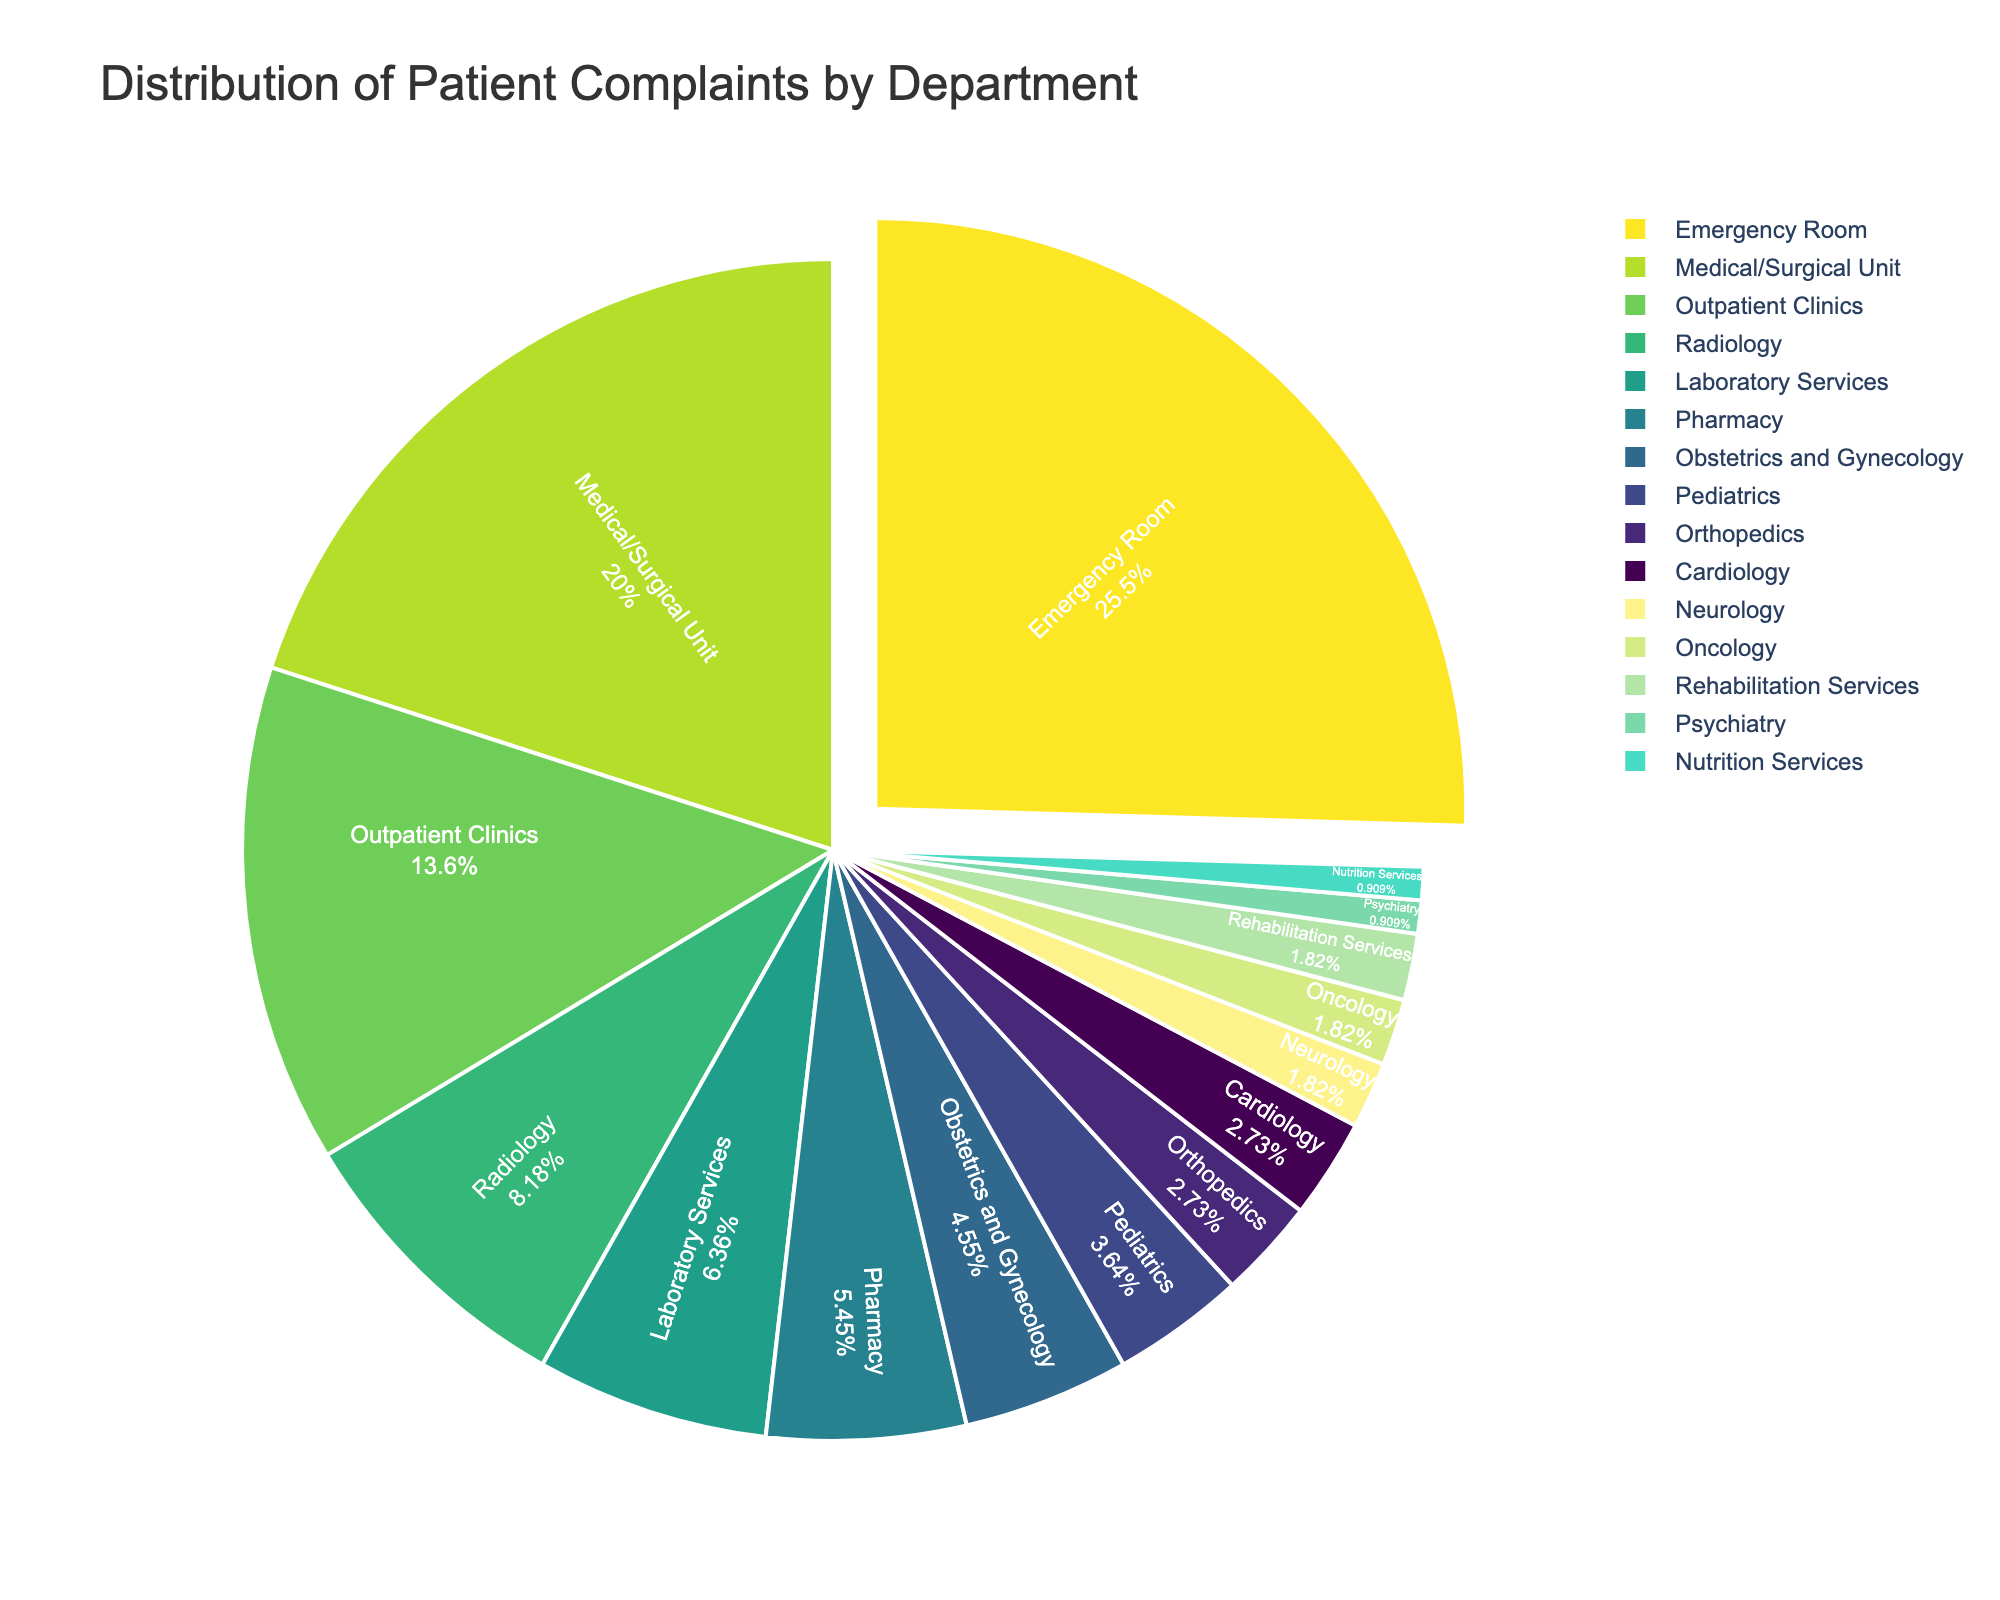What department has the highest percentage of patient complaints? The figure shows that the Emergency Room has the largest segment, which indicates it has the highest percentage of patient complaints.
Answer: Emergency Room Which department has fewer complaints, Orthopedics or Cardiology? Both Orthopedics and Cardiology are represented as small segments. By comparing the labeled percentages, it's visible that both have 3%. Therefore, they have the same percentage of complaints.
Answer: Orthopedics and Cardiology have the same percentage of complaints What is the combined percentage of complaints from the Radiology and Laboratory Services departments? The percentage for Radiology is 9% and for Laboratory Services is 7%. Adding them together gives 9% + 7% = 16%.
Answer: 16% Which two departments have the lowest percentage of complaints? The smallest segments in the pie chart represent Psychiatry and Nutrition Services, each labeled with 1%.
Answer: Psychiatry and Nutrition Services What is the sum of the percentages for Pediatrics, Orthopedics, Cardiology, Neurology, Oncology, Rehabilitation Services, Psychiatry, and Nutrition Services? The percentages for these departments are:
Pediatrics: 4%, Orthopedics: 3%, Cardiology: 3%, Neurology: 2%, Oncology: 2%, Rehabilitation Services: 2%, Psychiatry: 1%, Nutrition Services: 1%.
Adding these together: 4% + 3% + 3% + 2% + 2% + 2% + 1% + 1% = 18%.
Answer: 18% What percentage of complaints come from the departments with fewer than 5% complaints each? Departments with fewer than 5% include Obstetrics and Gynecology (5%), Pediatrics (4%), Orthopedics (3%), Cardiology (3%), Neurology (2%), Oncology (2%), Rehabilitation Services (2%), Psychiatry (1%), Nutrition Services (1%). Sum: 5% + 4% + 3% + 3% + 2% + 2% + 2% + 1% + 1% = 23%.
Answer: 23% Which department has more complaints, Outpatient Clinics or the Pharmacy? The Outpatient Clinics segment is larger than the Pharmacy segment with respective percentages of 15% and 6%.
Answer: Outpatient Clinics How many departments have a percentage of complaints greater than 10%? The segments with percentages greater than 10% are Emergency Room (28%) and Medical/Surgical Unit (22%). Hence, there are two departments.
Answer: 2 What visual attribute indicates which department has the highest complaints? The segment for the Emergency Room is slightly pulled out from the center of the pie chart, visually emphasizing it.
Answer: Pulled segment for the Emergency Room 